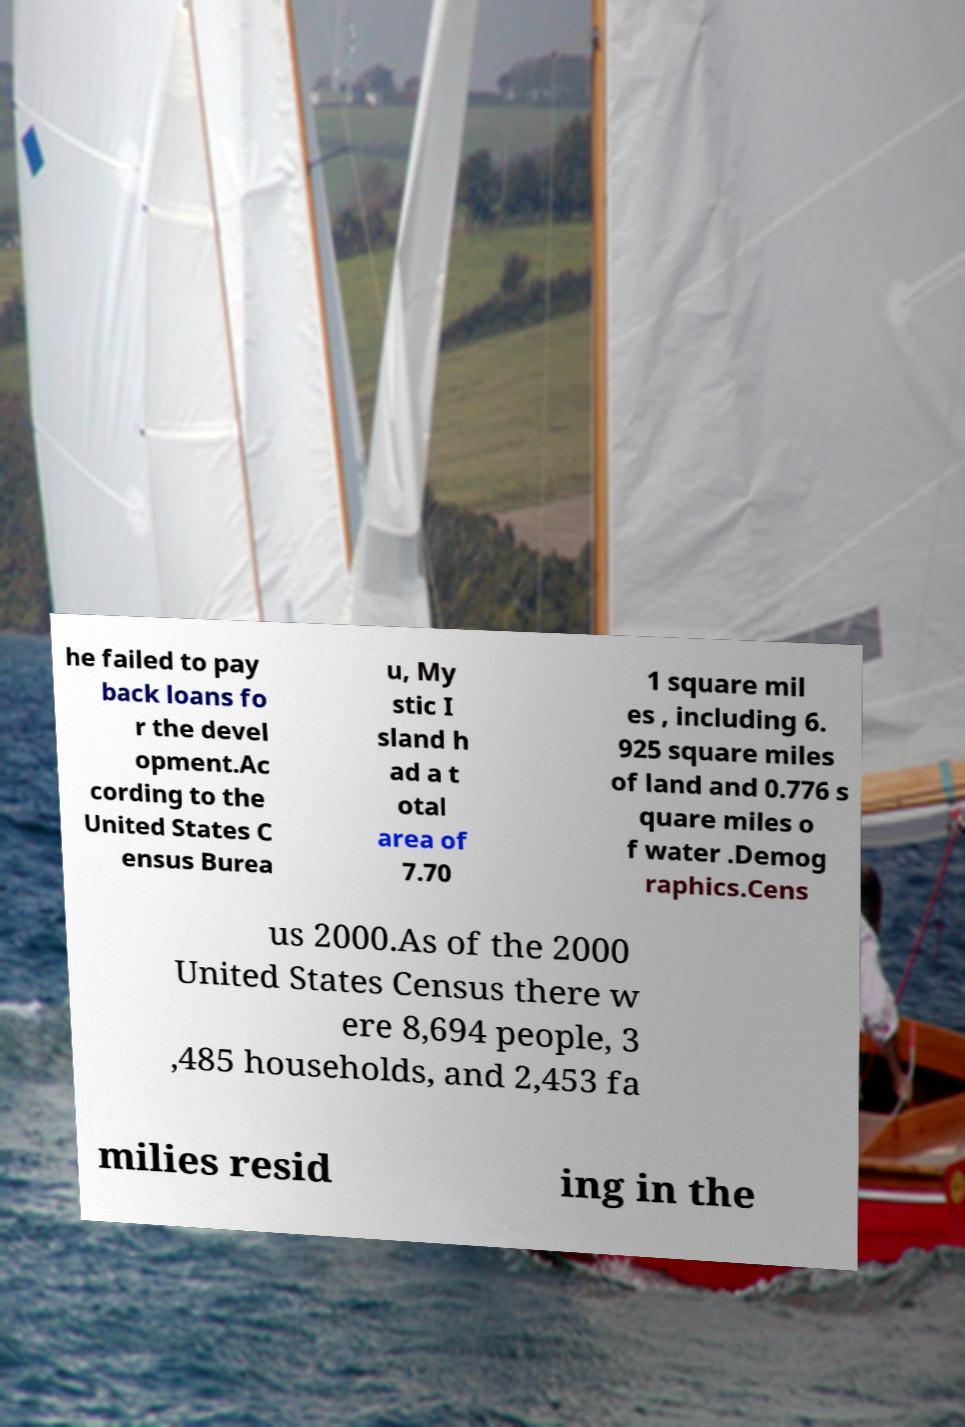Can you read and provide the text displayed in the image?This photo seems to have some interesting text. Can you extract and type it out for me? he failed to pay back loans fo r the devel opment.Ac cording to the United States C ensus Burea u, My stic I sland h ad a t otal area of 7.70 1 square mil es , including 6. 925 square miles of land and 0.776 s quare miles o f water .Demog raphics.Cens us 2000.As of the 2000 United States Census there w ere 8,694 people, 3 ,485 households, and 2,453 fa milies resid ing in the 